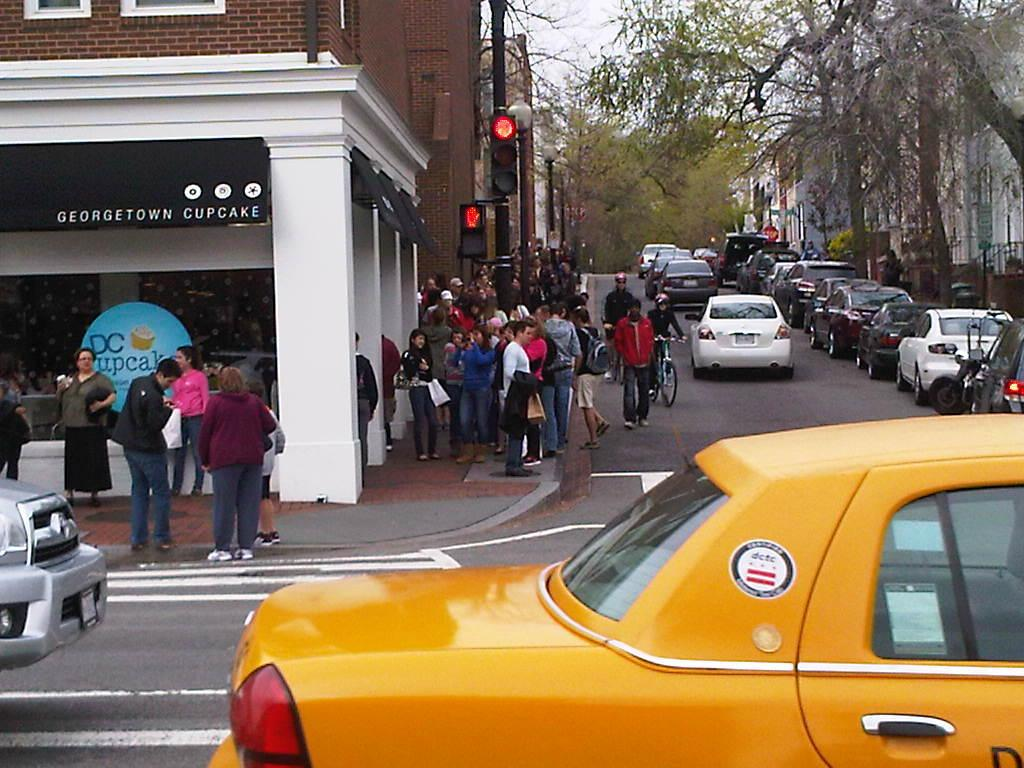<image>
Share a concise interpretation of the image provided. Georgetown Cupcake store on the left next to a Traffic Light on the right. 